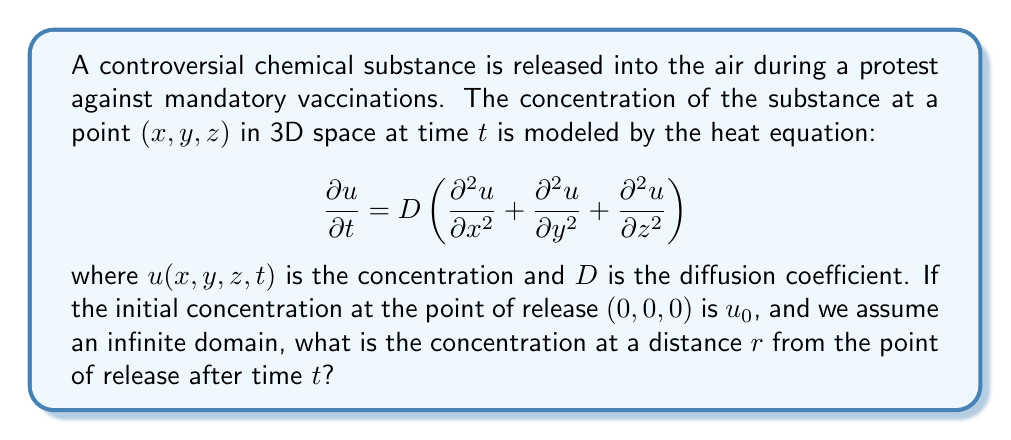Help me with this question. To solve this problem, we'll follow these steps:

1) The heat equation in 3D for radially symmetric problems can be written in spherical coordinates as:

   $$\frac{\partial u}{\partial t} = D\left(\frac{\partial^2 u}{\partial r^2} + \frac{2}{r}\frac{\partial u}{\partial r}\right)$$

2) For an instantaneous point source in an infinite domain, the solution is given by:

   $$u(r,t) = \frac{M}{(4\pi Dt)^{3/2}} \exp\left(-\frac{r^2}{4Dt}\right)$$

   where $M$ is the total amount of substance released.

3) To find $M$, we integrate the initial condition over all space:

   $$M = \int_{-\infty}^{\infty}\int_{-\infty}^{\infty}\int_{-\infty}^{\infty} u_0\delta(x)\delta(y)\delta(z) dx dy dz = u_0$$

4) Substituting this back into our solution:

   $$u(r,t) = \frac{u_0}{(4\pi Dt)^{3/2}} \exp\left(-\frac{r^2}{4Dt}\right)$$

This gives us the concentration at a distance $r$ from the point of release after time $t$.
Answer: $u(r,t) = \frac{u_0}{(4\pi Dt)^{3/2}} \exp\left(-\frac{r^2}{4Dt}\right)$ 